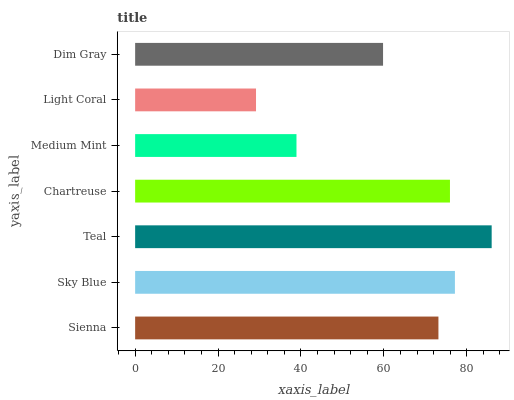Is Light Coral the minimum?
Answer yes or no. Yes. Is Teal the maximum?
Answer yes or no. Yes. Is Sky Blue the minimum?
Answer yes or no. No. Is Sky Blue the maximum?
Answer yes or no. No. Is Sky Blue greater than Sienna?
Answer yes or no. Yes. Is Sienna less than Sky Blue?
Answer yes or no. Yes. Is Sienna greater than Sky Blue?
Answer yes or no. No. Is Sky Blue less than Sienna?
Answer yes or no. No. Is Sienna the high median?
Answer yes or no. Yes. Is Sienna the low median?
Answer yes or no. Yes. Is Dim Gray the high median?
Answer yes or no. No. Is Light Coral the low median?
Answer yes or no. No. 